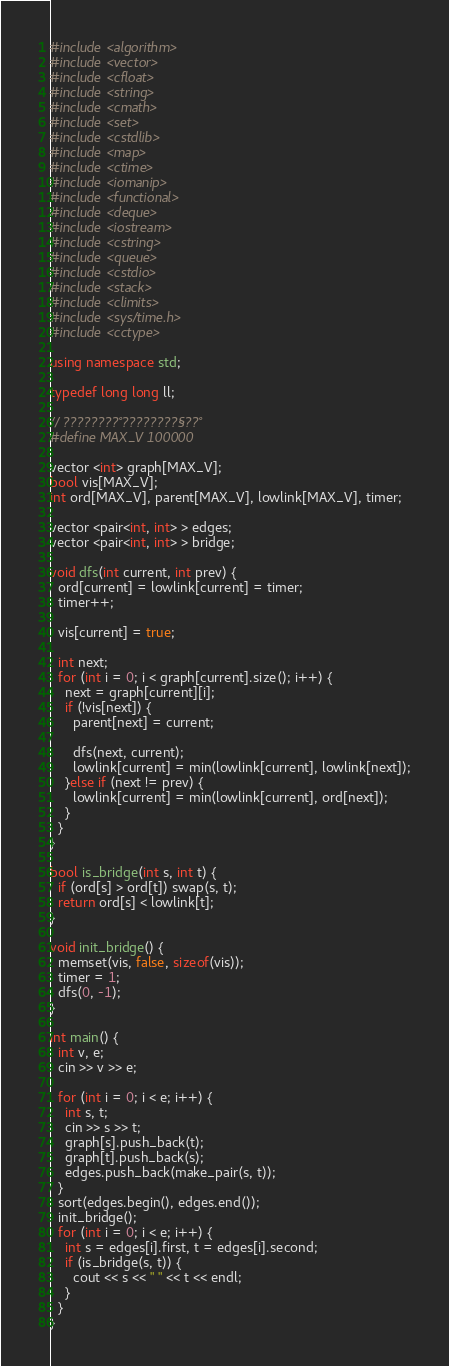Convert code to text. <code><loc_0><loc_0><loc_500><loc_500><_C++_>#include <algorithm>
#include <vector>
#include <cfloat>
#include <string>
#include <cmath>
#include <set>
#include <cstdlib>
#include <map>
#include <ctime>
#include <iomanip>
#include <functional>
#include <deque>
#include <iostream>
#include <cstring>
#include <queue>
#include <cstdio>
#include <stack>
#include <climits>
#include <sys/time.h>
#include <cctype>

using namespace std;

typedef long long ll;

// ????????°????????§??°
#define MAX_V 100000

vector <int> graph[MAX_V];
bool vis[MAX_V];
int ord[MAX_V], parent[MAX_V], lowlink[MAX_V], timer;

vector <pair<int, int> > edges;
vector <pair<int, int> > bridge;

void dfs(int current, int prev) {
  ord[current] = lowlink[current] = timer;
  timer++;

  vis[current] = true;

  int next;
  for (int i = 0; i < graph[current].size(); i++) {
    next = graph[current][i];
    if (!vis[next]) {
      parent[next] = current;

      dfs(next, current);
      lowlink[current] = min(lowlink[current], lowlink[next]);
    }else if (next != prev) {
      lowlink[current] = min(lowlink[current], ord[next]);
    }
  }
}

bool is_bridge(int s, int t) {
  if (ord[s] > ord[t]) swap(s, t);
  return ord[s] < lowlink[t];
}

void init_bridge() {
  memset(vis, false, sizeof(vis));
  timer = 1;
  dfs(0, -1);
}

int main() {
  int v, e;
  cin >> v >> e;

  for (int i = 0; i < e; i++) {
    int s, t;
    cin >> s >> t;
    graph[s].push_back(t);
    graph[t].push_back(s);
    edges.push_back(make_pair(s, t));
  }
  sort(edges.begin(), edges.end());
  init_bridge();
  for (int i = 0; i < e; i++) {
    int s = edges[i].first, t = edges[i].second;
    if (is_bridge(s, t)) {
      cout << s << " " << t << endl;
    }
  }
}</code> 